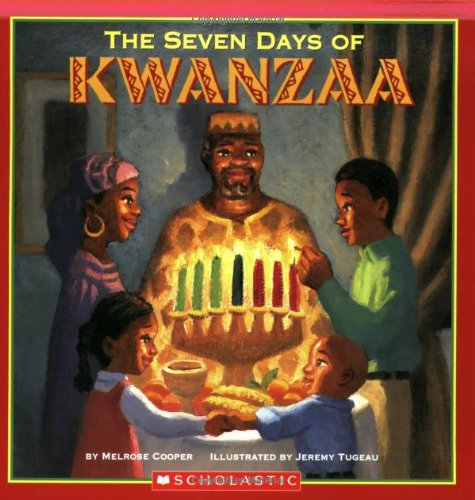What is the title of this book? The title of the book depicted in the image is 'Seven Days Of Kwanzaa.' It explores the week-long celebration known as Kwanzaa through vivid storytelling and illustrations. 